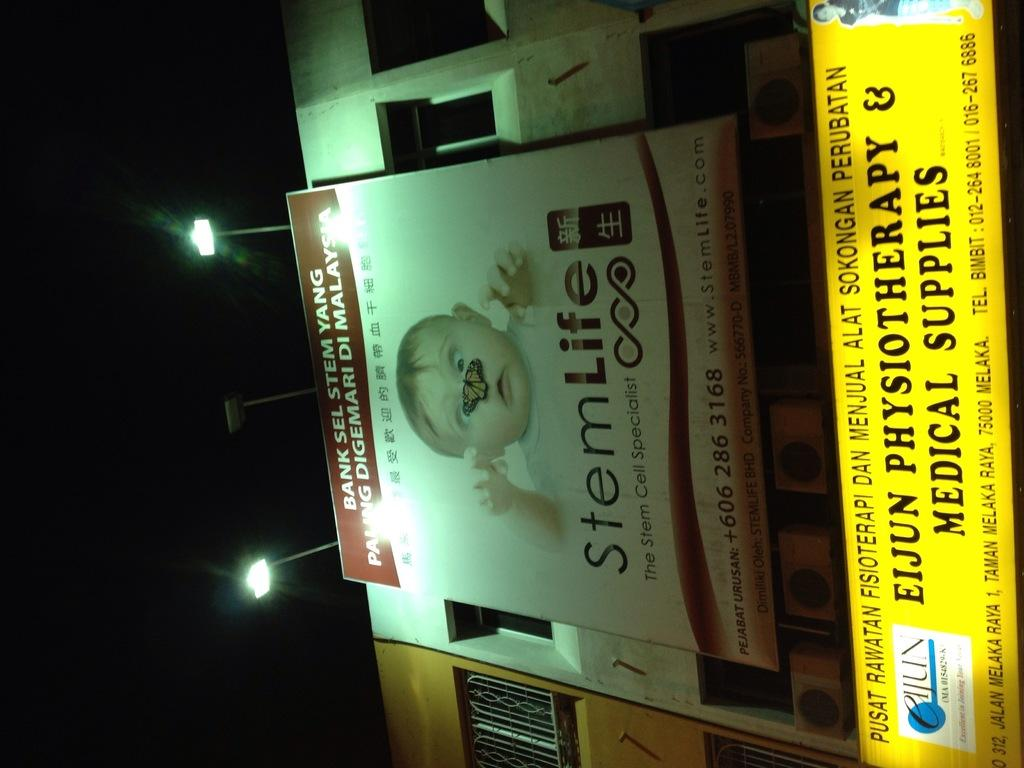<image>
Relay a brief, clear account of the picture shown. A billboard for StemLife pictures a baby with a butterfly on it's nose to advertise service for stem cells. 